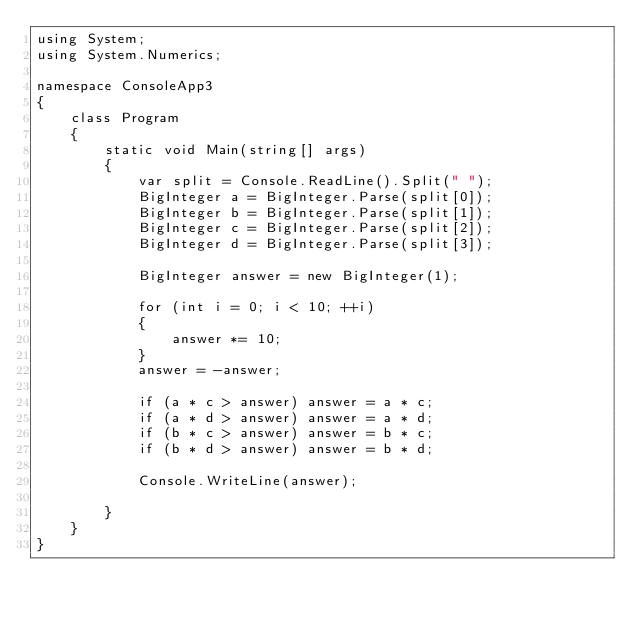<code> <loc_0><loc_0><loc_500><loc_500><_C#_>using System;
using System.Numerics;

namespace ConsoleApp3
{
    class Program
    {
        static void Main(string[] args)
        {
            var split = Console.ReadLine().Split(" ");
            BigInteger a = BigInteger.Parse(split[0]);
            BigInteger b = BigInteger.Parse(split[1]);
            BigInteger c = BigInteger.Parse(split[2]);
            BigInteger d = BigInteger.Parse(split[3]);

            BigInteger answer = new BigInteger(1);

            for (int i = 0; i < 10; ++i)
            {
                answer *= 10;
            }
            answer = -answer;

            if (a * c > answer) answer = a * c;
            if (a * d > answer) answer = a * d;
            if (b * c > answer) answer = b * c;
            if (b * d > answer) answer = b * d;

            Console.WriteLine(answer);

        }
    }
}
</code> 